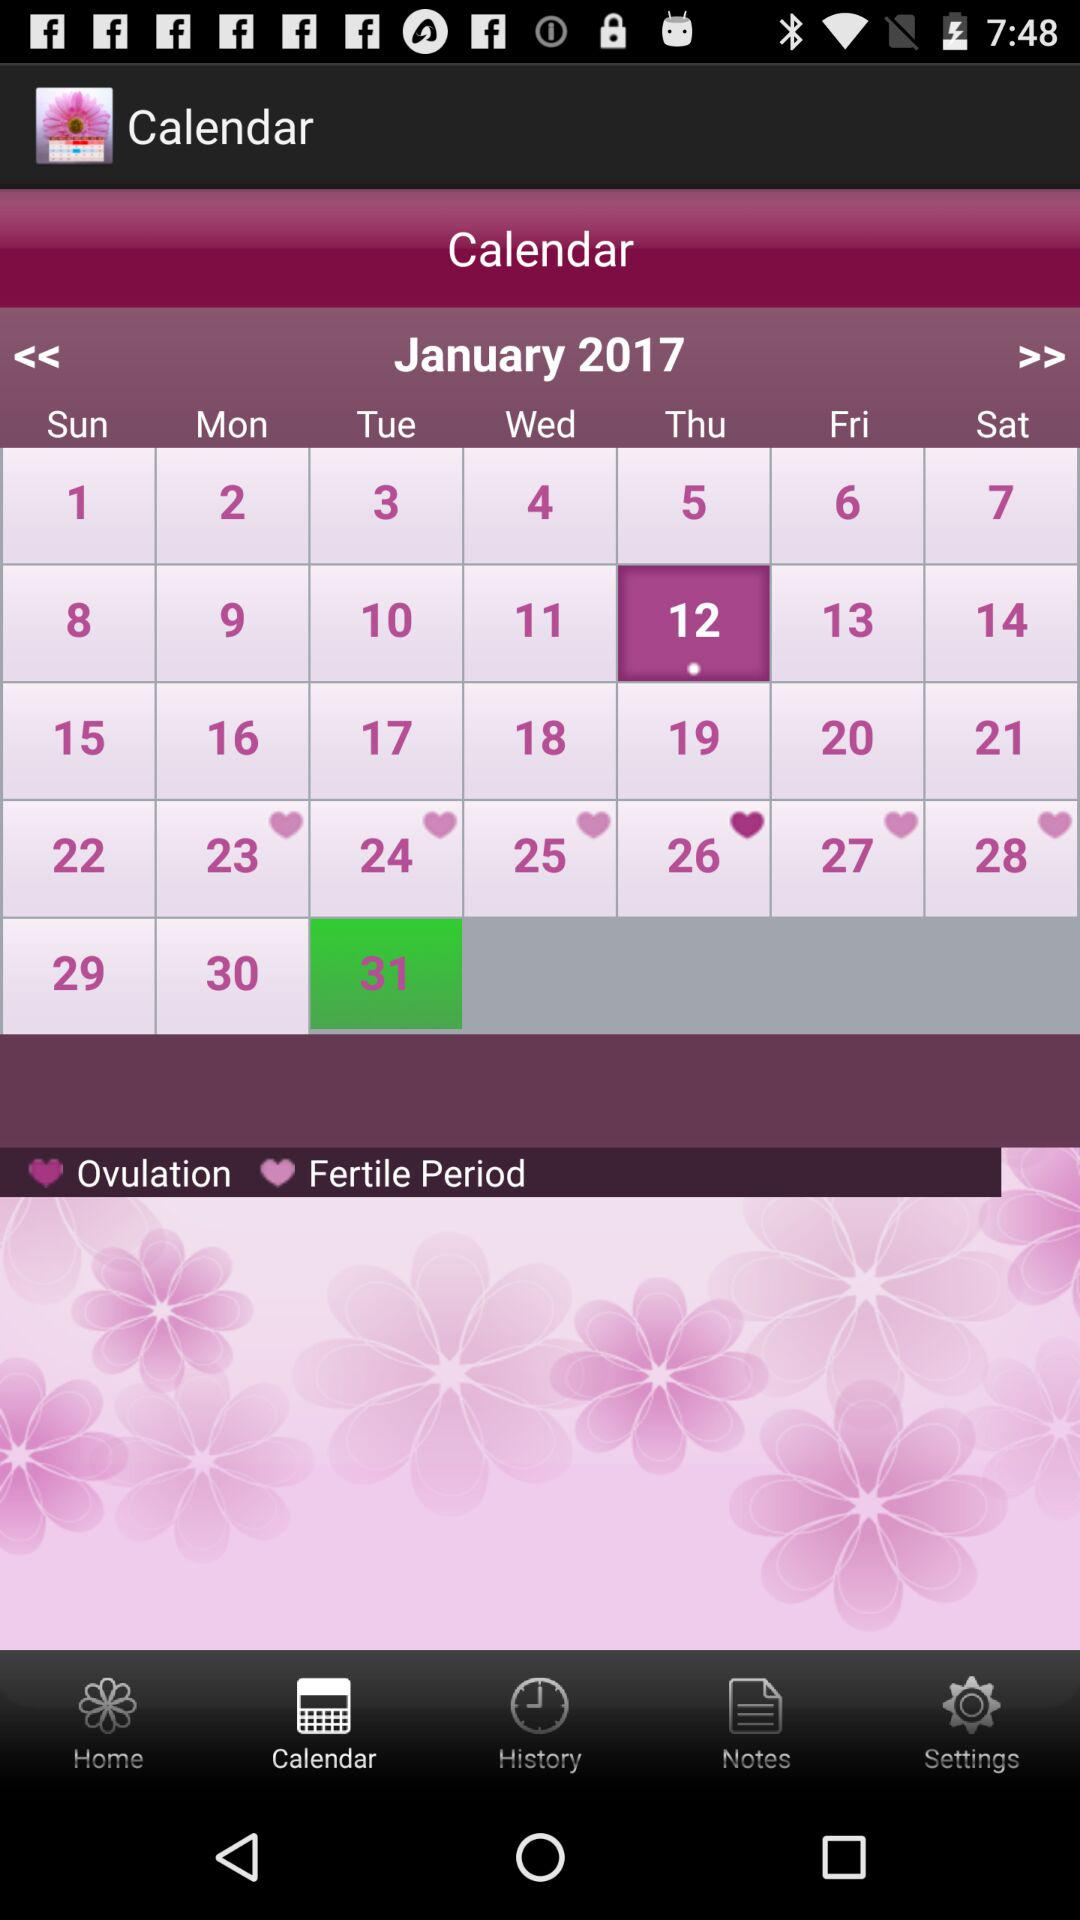Which tab is selected? The selected tab is "Calendar". 